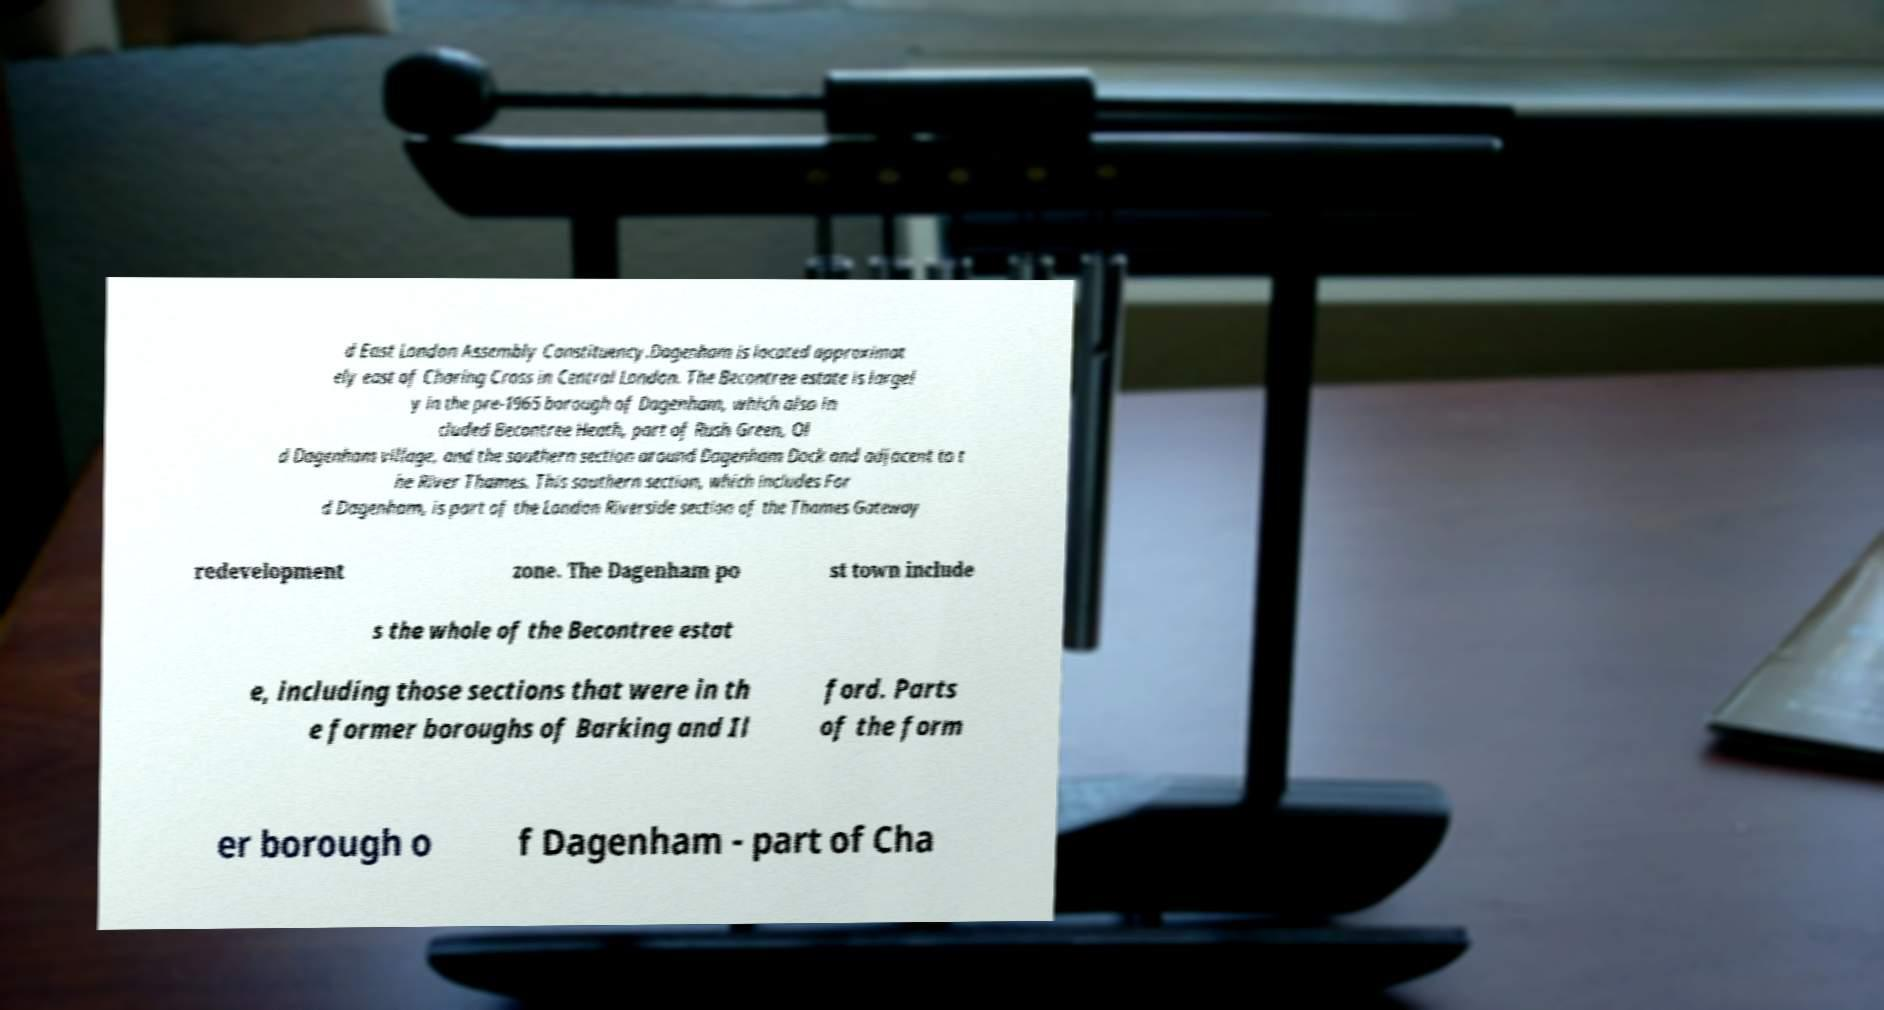Could you extract and type out the text from this image? d East London Assembly Constituency.Dagenham is located approximat ely east of Charing Cross in Central London. The Becontree estate is largel y in the pre-1965 borough of Dagenham, which also in cluded Becontree Heath, part of Rush Green, Ol d Dagenham village, and the southern section around Dagenham Dock and adjacent to t he River Thames. This southern section, which includes For d Dagenham, is part of the London Riverside section of the Thames Gateway redevelopment zone. The Dagenham po st town include s the whole of the Becontree estat e, including those sections that were in th e former boroughs of Barking and Il ford. Parts of the form er borough o f Dagenham - part of Cha 